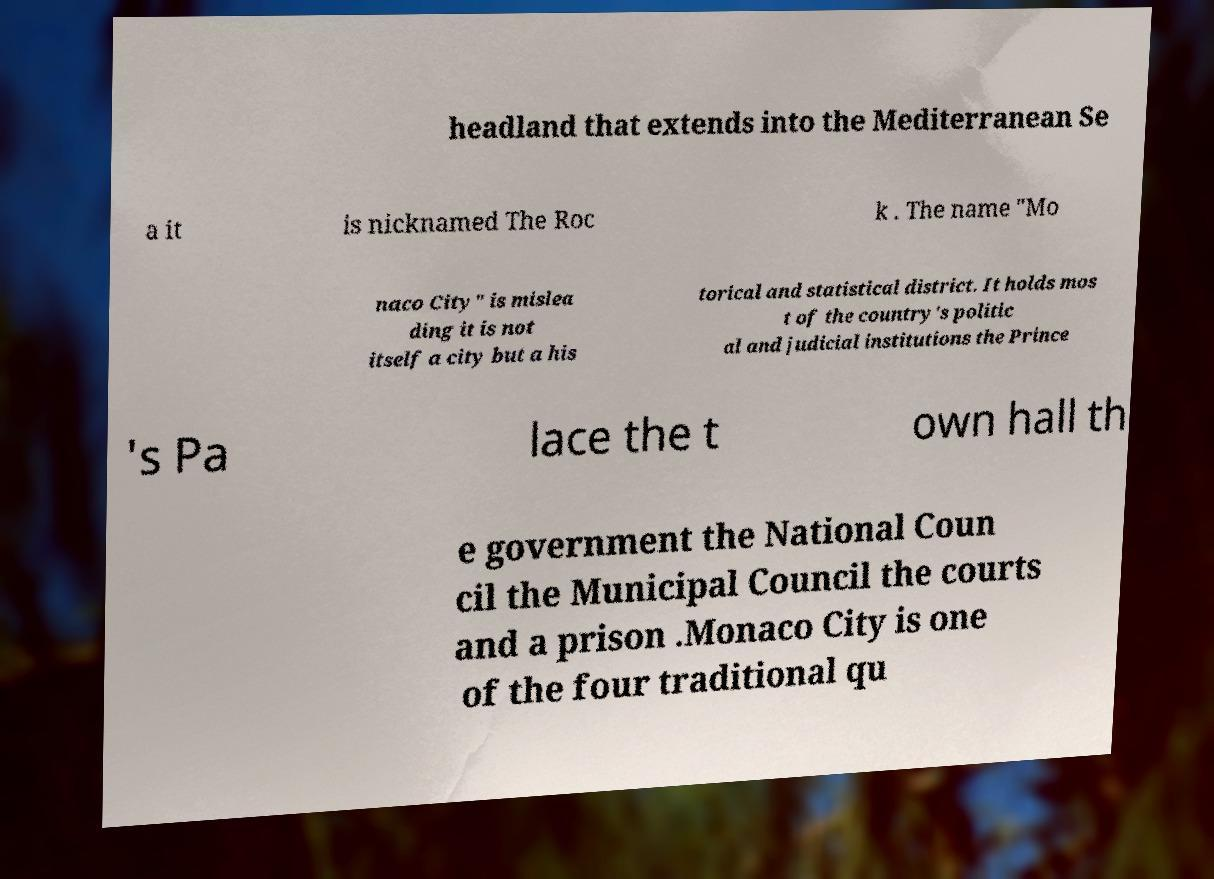Could you extract and type out the text from this image? headland that extends into the Mediterranean Se a it is nicknamed The Roc k . The name "Mo naco City" is mislea ding it is not itself a city but a his torical and statistical district. It holds mos t of the country's politic al and judicial institutions the Prince 's Pa lace the t own hall th e government the National Coun cil the Municipal Council the courts and a prison .Monaco City is one of the four traditional qu 